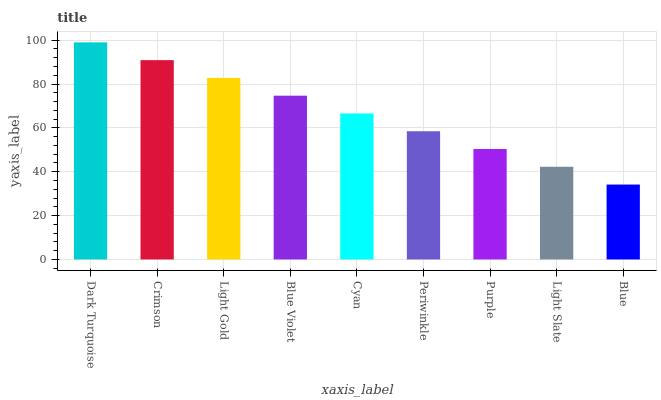Is Blue the minimum?
Answer yes or no. Yes. Is Dark Turquoise the maximum?
Answer yes or no. Yes. Is Crimson the minimum?
Answer yes or no. No. Is Crimson the maximum?
Answer yes or no. No. Is Dark Turquoise greater than Crimson?
Answer yes or no. Yes. Is Crimson less than Dark Turquoise?
Answer yes or no. Yes. Is Crimson greater than Dark Turquoise?
Answer yes or no. No. Is Dark Turquoise less than Crimson?
Answer yes or no. No. Is Cyan the high median?
Answer yes or no. Yes. Is Cyan the low median?
Answer yes or no. Yes. Is Dark Turquoise the high median?
Answer yes or no. No. Is Blue the low median?
Answer yes or no. No. 